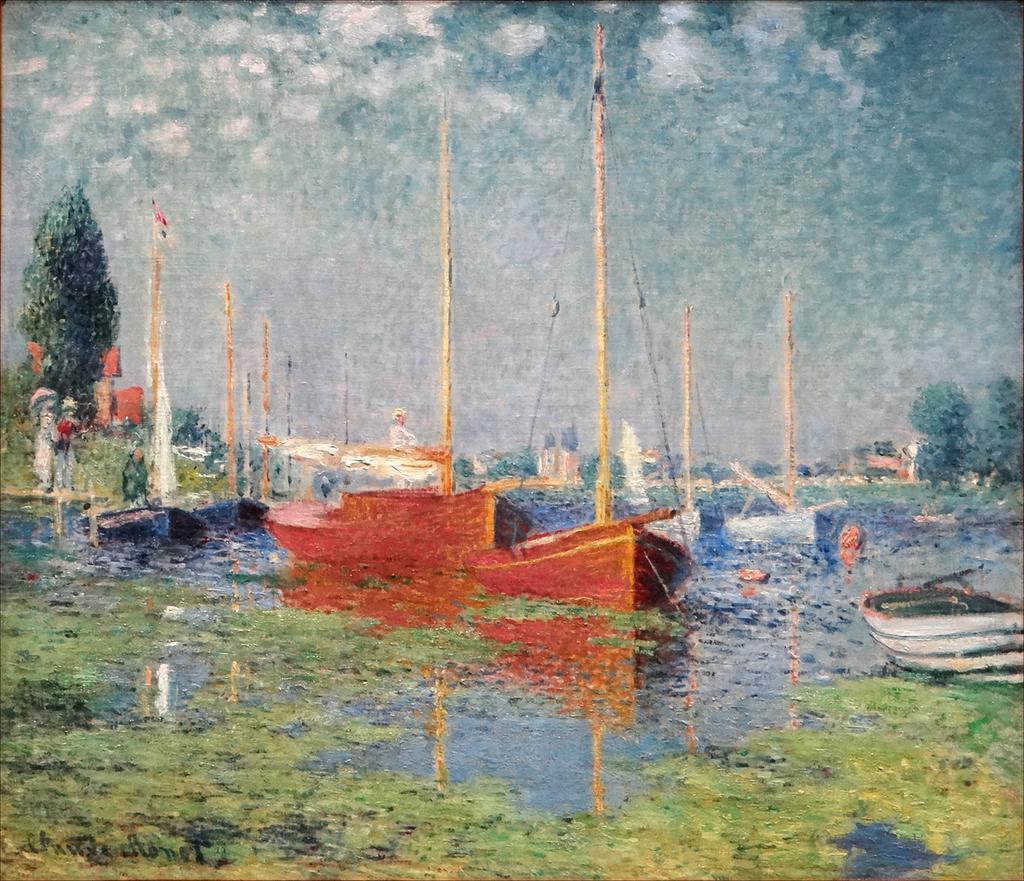Can you describe this image briefly? In the image there is a painting. At the bottom of the image there is water. On the water there are boats with poles and also there are trees in the background. In the background there is sky. 